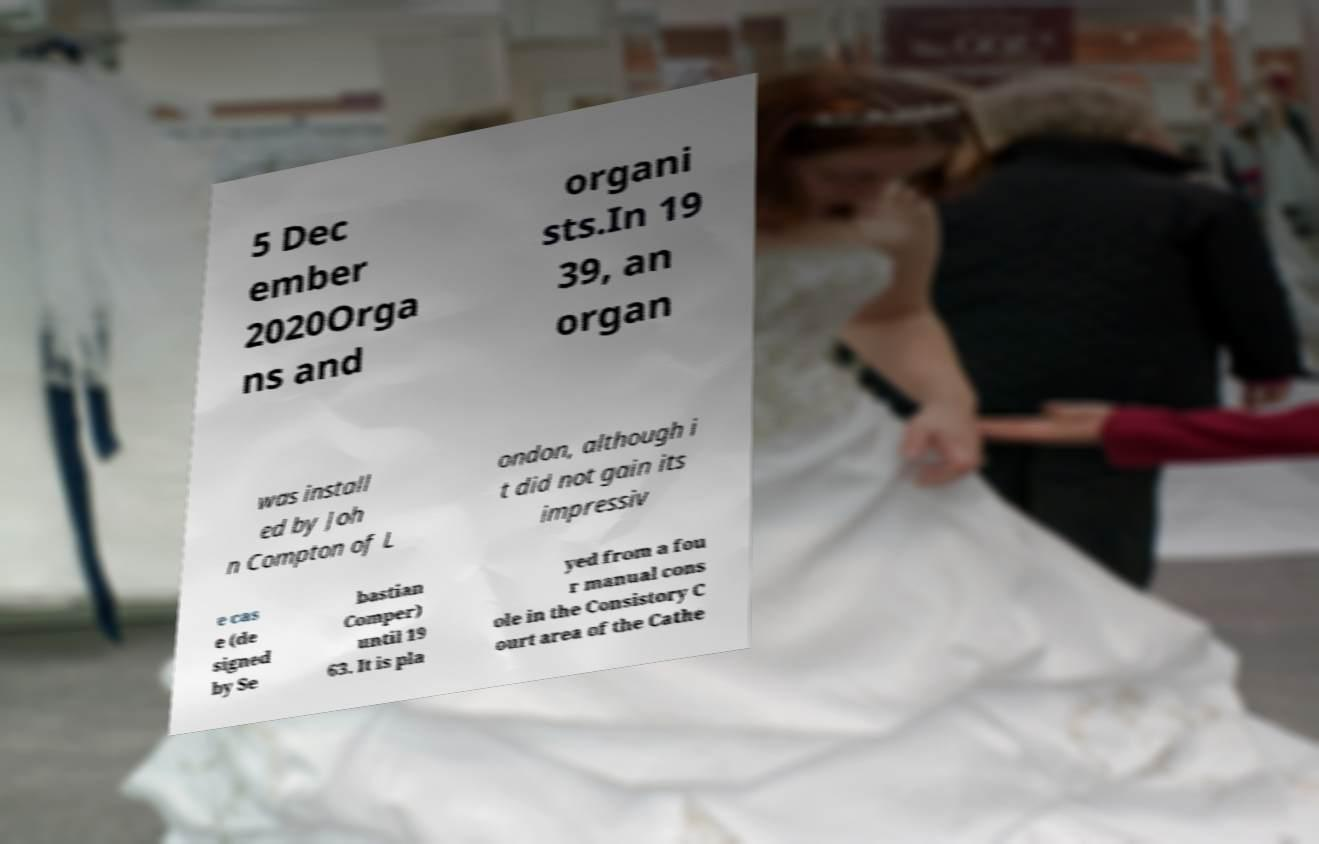I need the written content from this picture converted into text. Can you do that? 5 Dec ember 2020Orga ns and organi sts.In 19 39, an organ was install ed by Joh n Compton of L ondon, although i t did not gain its impressiv e cas e (de signed by Se bastian Comper) until 19 63. It is pla yed from a fou r manual cons ole in the Consistory C ourt area of the Cathe 